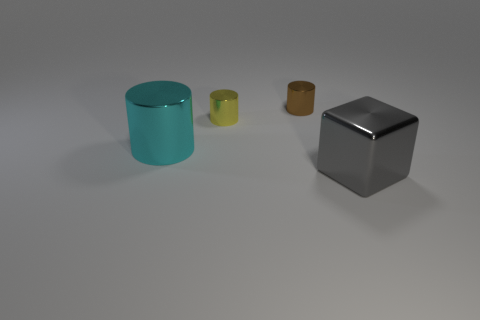Add 2 small yellow metallic things. How many objects exist? 6 Subtract all cylinders. How many objects are left? 1 Subtract 0 purple cubes. How many objects are left? 4 Subtract all large metallic things. Subtract all large metal cylinders. How many objects are left? 1 Add 4 cyan cylinders. How many cyan cylinders are left? 5 Add 4 big gray metallic cubes. How many big gray metallic cubes exist? 5 